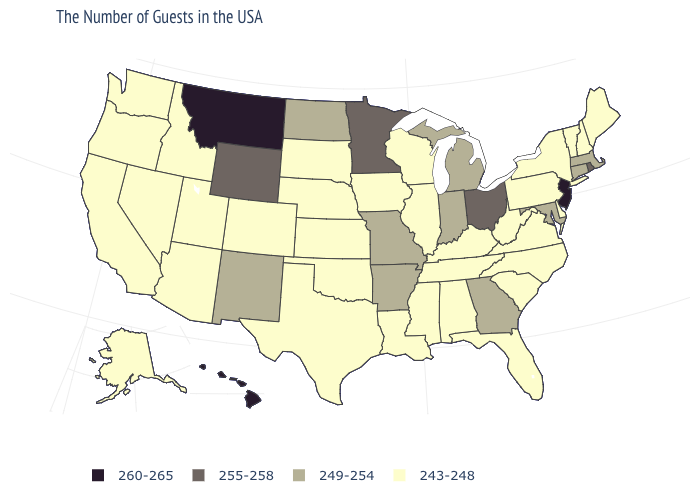Which states hav the highest value in the West?
Keep it brief. Montana, Hawaii. What is the value of Arizona?
Keep it brief. 243-248. What is the value of Hawaii?
Short answer required. 260-265. What is the highest value in the USA?
Short answer required. 260-265. Is the legend a continuous bar?
Answer briefly. No. Does the first symbol in the legend represent the smallest category?
Short answer required. No. Does New Jersey have the highest value in the Northeast?
Keep it brief. Yes. What is the value of Maine?
Short answer required. 243-248. Does Minnesota have the highest value in the MidWest?
Be succinct. Yes. What is the value of Nebraska?
Answer briefly. 243-248. Which states have the highest value in the USA?
Short answer required. New Jersey, Montana, Hawaii. What is the value of Montana?
Quick response, please. 260-265. Name the states that have a value in the range 255-258?
Be succinct. Rhode Island, Ohio, Minnesota, Wyoming. What is the value of Montana?
Concise answer only. 260-265. Name the states that have a value in the range 243-248?
Answer briefly. Maine, New Hampshire, Vermont, New York, Delaware, Pennsylvania, Virginia, North Carolina, South Carolina, West Virginia, Florida, Kentucky, Alabama, Tennessee, Wisconsin, Illinois, Mississippi, Louisiana, Iowa, Kansas, Nebraska, Oklahoma, Texas, South Dakota, Colorado, Utah, Arizona, Idaho, Nevada, California, Washington, Oregon, Alaska. 